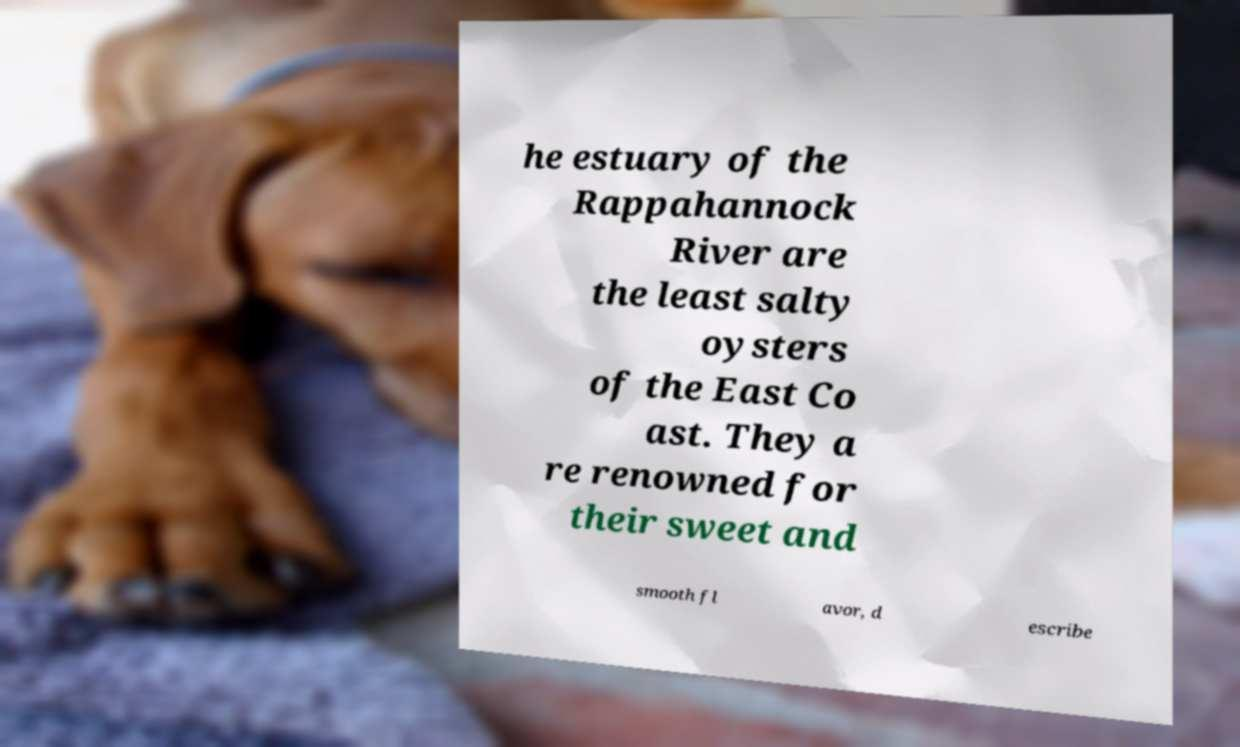Please read and relay the text visible in this image. What does it say? he estuary of the Rappahannock River are the least salty oysters of the East Co ast. They a re renowned for their sweet and smooth fl avor, d escribe 